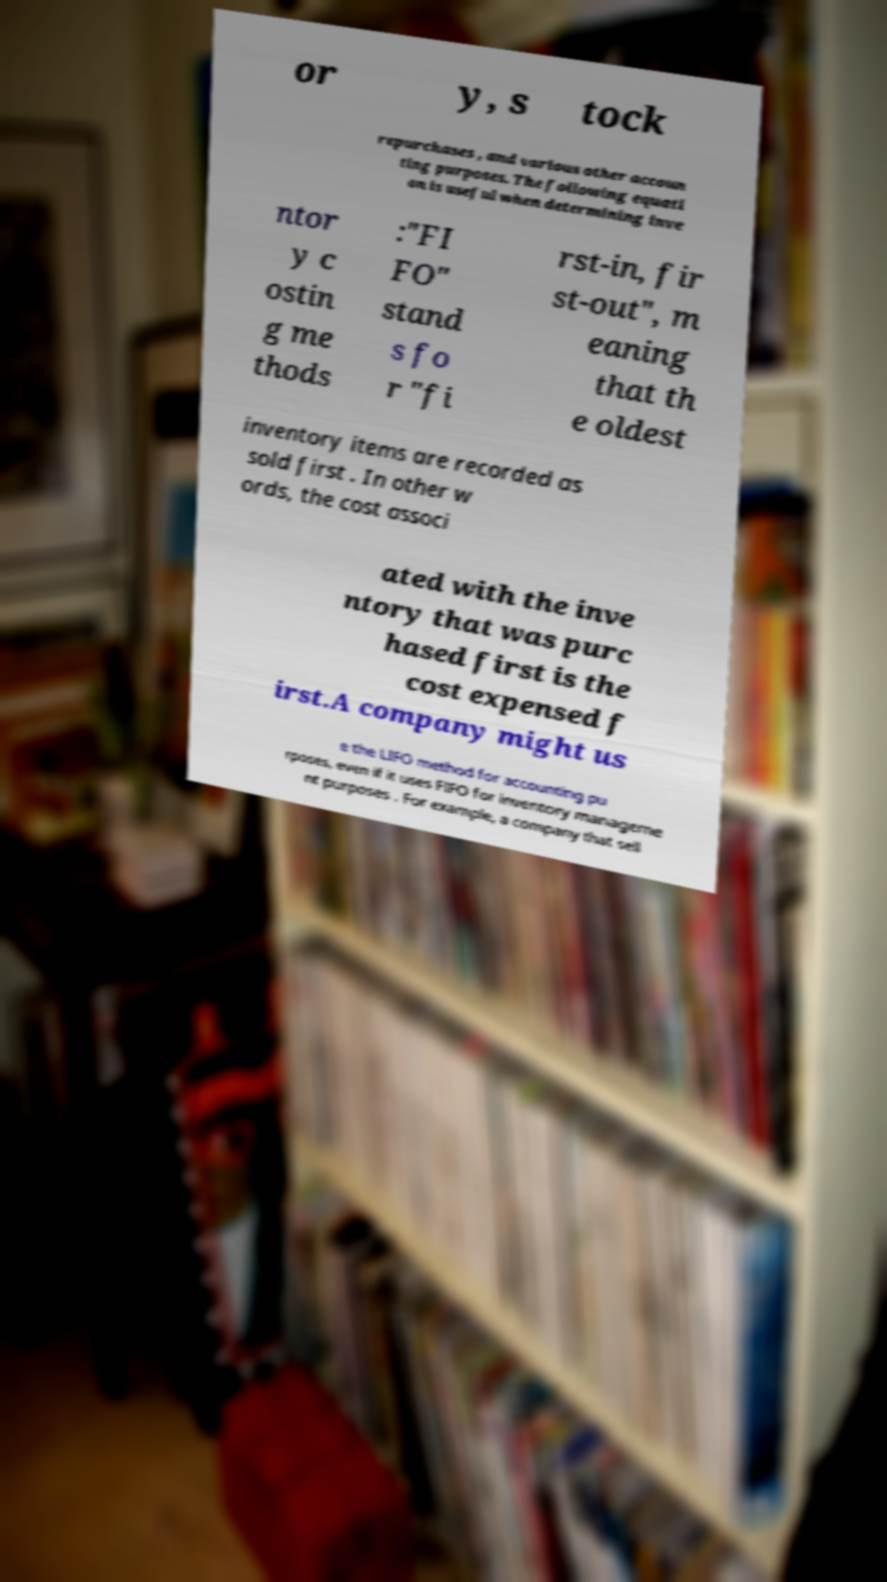Please read and relay the text visible in this image. What does it say? or y, s tock repurchases , and various other accoun ting purposes. The following equati on is useful when determining inve ntor y c ostin g me thods :"FI FO" stand s fo r "fi rst-in, fir st-out", m eaning that th e oldest inventory items are recorded as sold first . In other w ords, the cost associ ated with the inve ntory that was purc hased first is the cost expensed f irst.A company might us e the LIFO method for accounting pu rposes, even if it uses FIFO for inventory manageme nt purposes . For example, a company that sell 